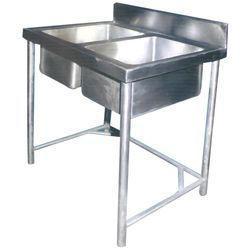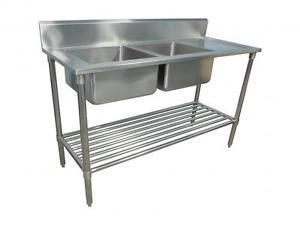The first image is the image on the left, the second image is the image on the right. Given the left and right images, does the statement "Design features present in the combined images include a railed lower shelf, and extra open space on the right of two stainless steel sinks in one unit." hold true? Answer yes or no. Yes. 